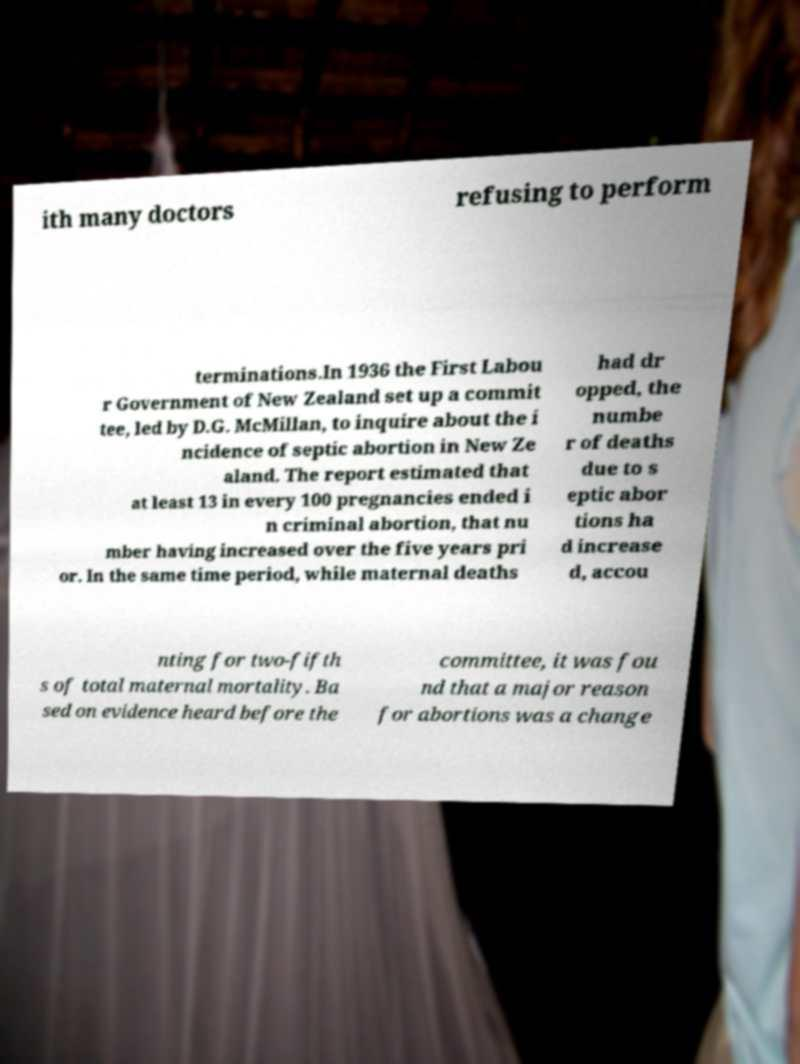Please read and relay the text visible in this image. What does it say? ith many doctors refusing to perform terminations.In 1936 the First Labou r Government of New Zealand set up a commit tee, led by D.G. McMillan, to inquire about the i ncidence of septic abortion in New Ze aland. The report estimated that at least 13 in every 100 pregnancies ended i n criminal abortion, that nu mber having increased over the five years pri or. In the same time period, while maternal deaths had dr opped, the numbe r of deaths due to s eptic abor tions ha d increase d, accou nting for two-fifth s of total maternal mortality. Ba sed on evidence heard before the committee, it was fou nd that a major reason for abortions was a change 